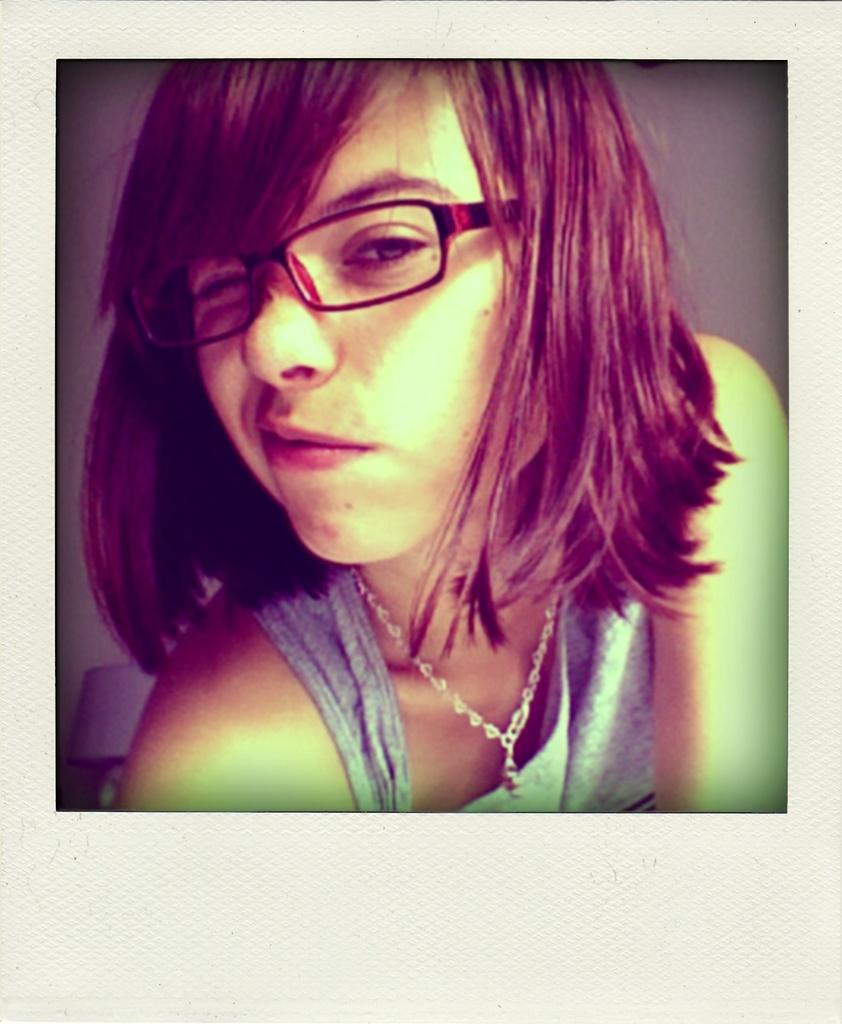What is the main subject of the image? The main subject of the image is a woman. What can be observed about the woman's appearance? The woman is wearing spectacles. What is visible in the background of the image? There is a wall in the background of the image. What is the existence of the edge of the universe in the image? The image does not depict the edge of the universe; it features a woman and a wall in the background. 